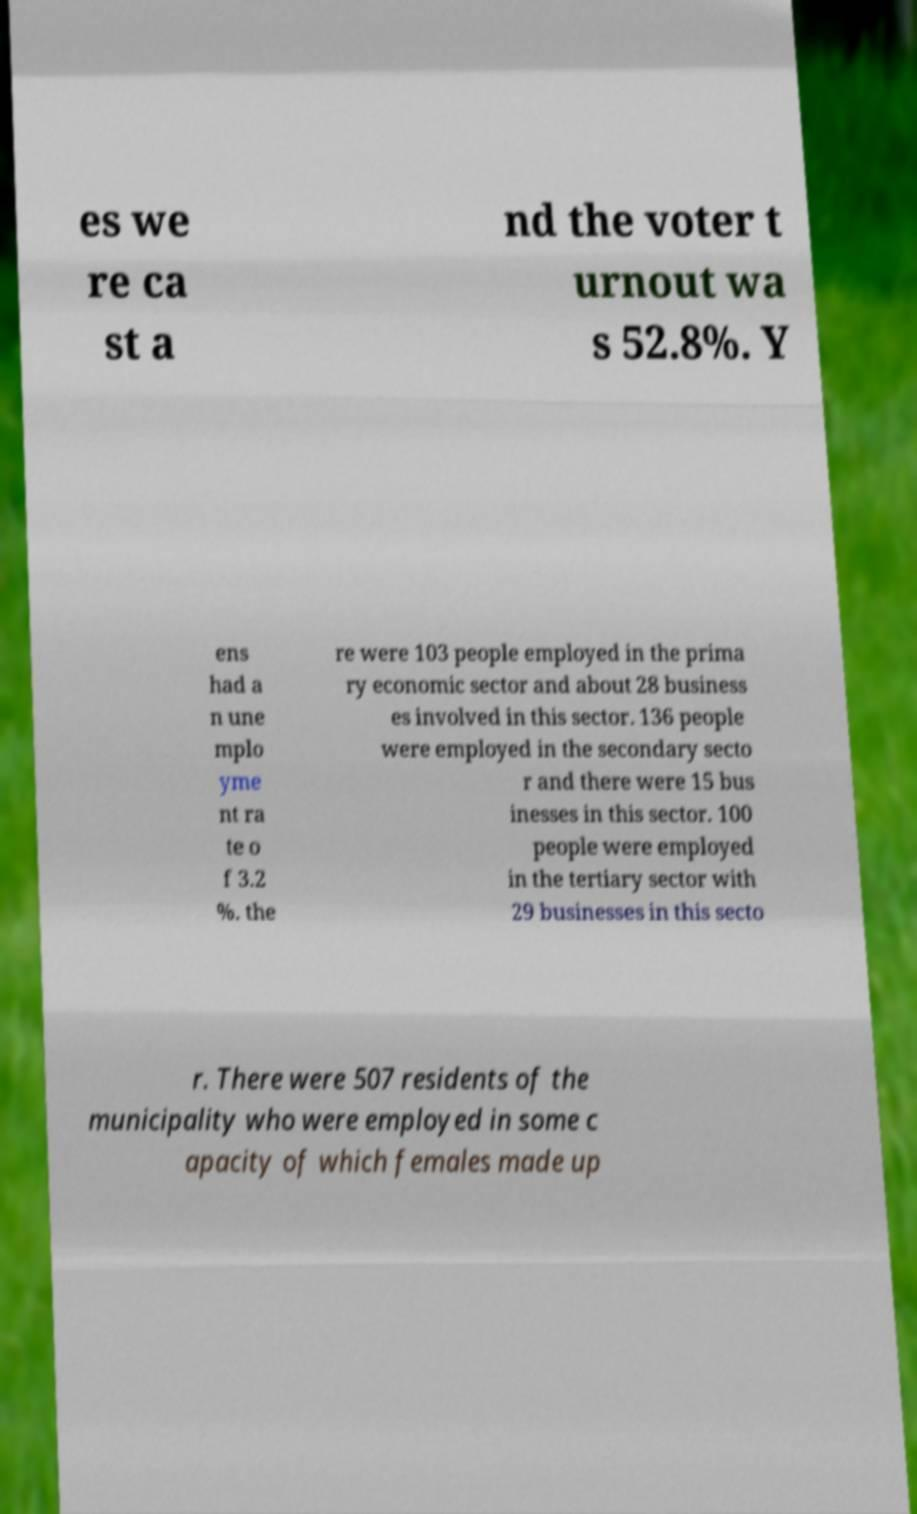For documentation purposes, I need the text within this image transcribed. Could you provide that? es we re ca st a nd the voter t urnout wa s 52.8%. Y ens had a n une mplo yme nt ra te o f 3.2 %. the re were 103 people employed in the prima ry economic sector and about 28 business es involved in this sector. 136 people were employed in the secondary secto r and there were 15 bus inesses in this sector. 100 people were employed in the tertiary sector with 29 businesses in this secto r. There were 507 residents of the municipality who were employed in some c apacity of which females made up 